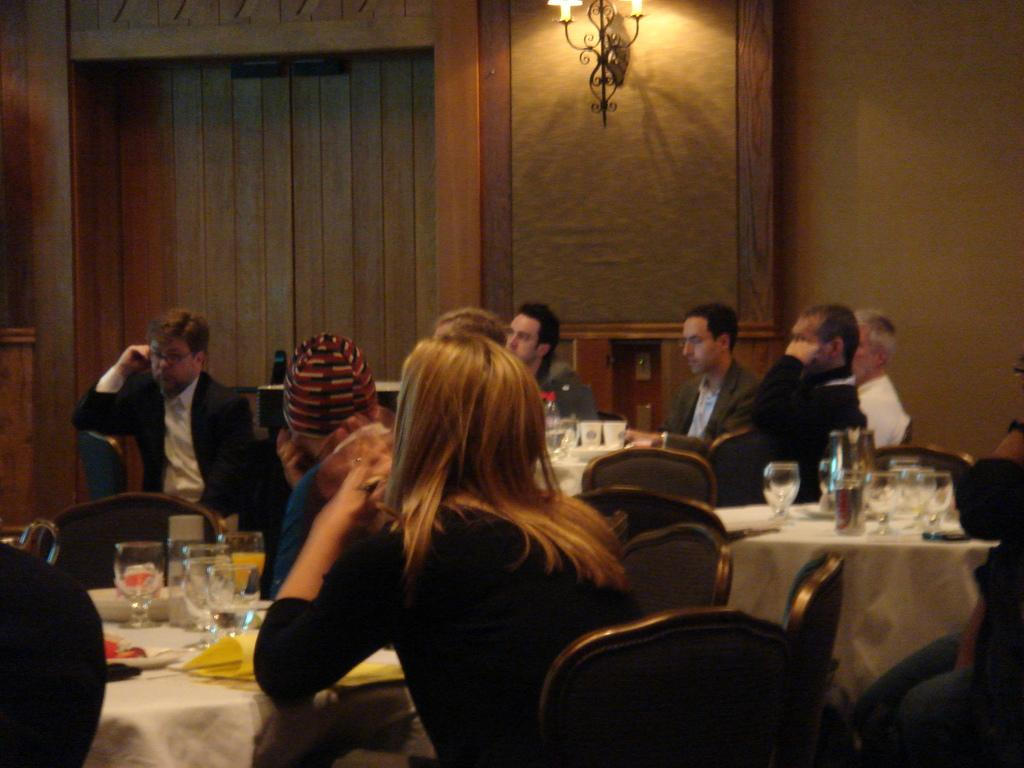What is happening in the image involving a group of people? There is a group of people sitting together in the image. What furniture is present in the image for the people to sit on? There are chairs in the image for the people to sit on. What can be seen on the table in the image? There are wine glasses on the table in the image. What type of lighting is present in the image? There are lights on the wall at the top of the image. What color is the sweater worn by the rock in the image? There is no rock or sweater present in the image. 